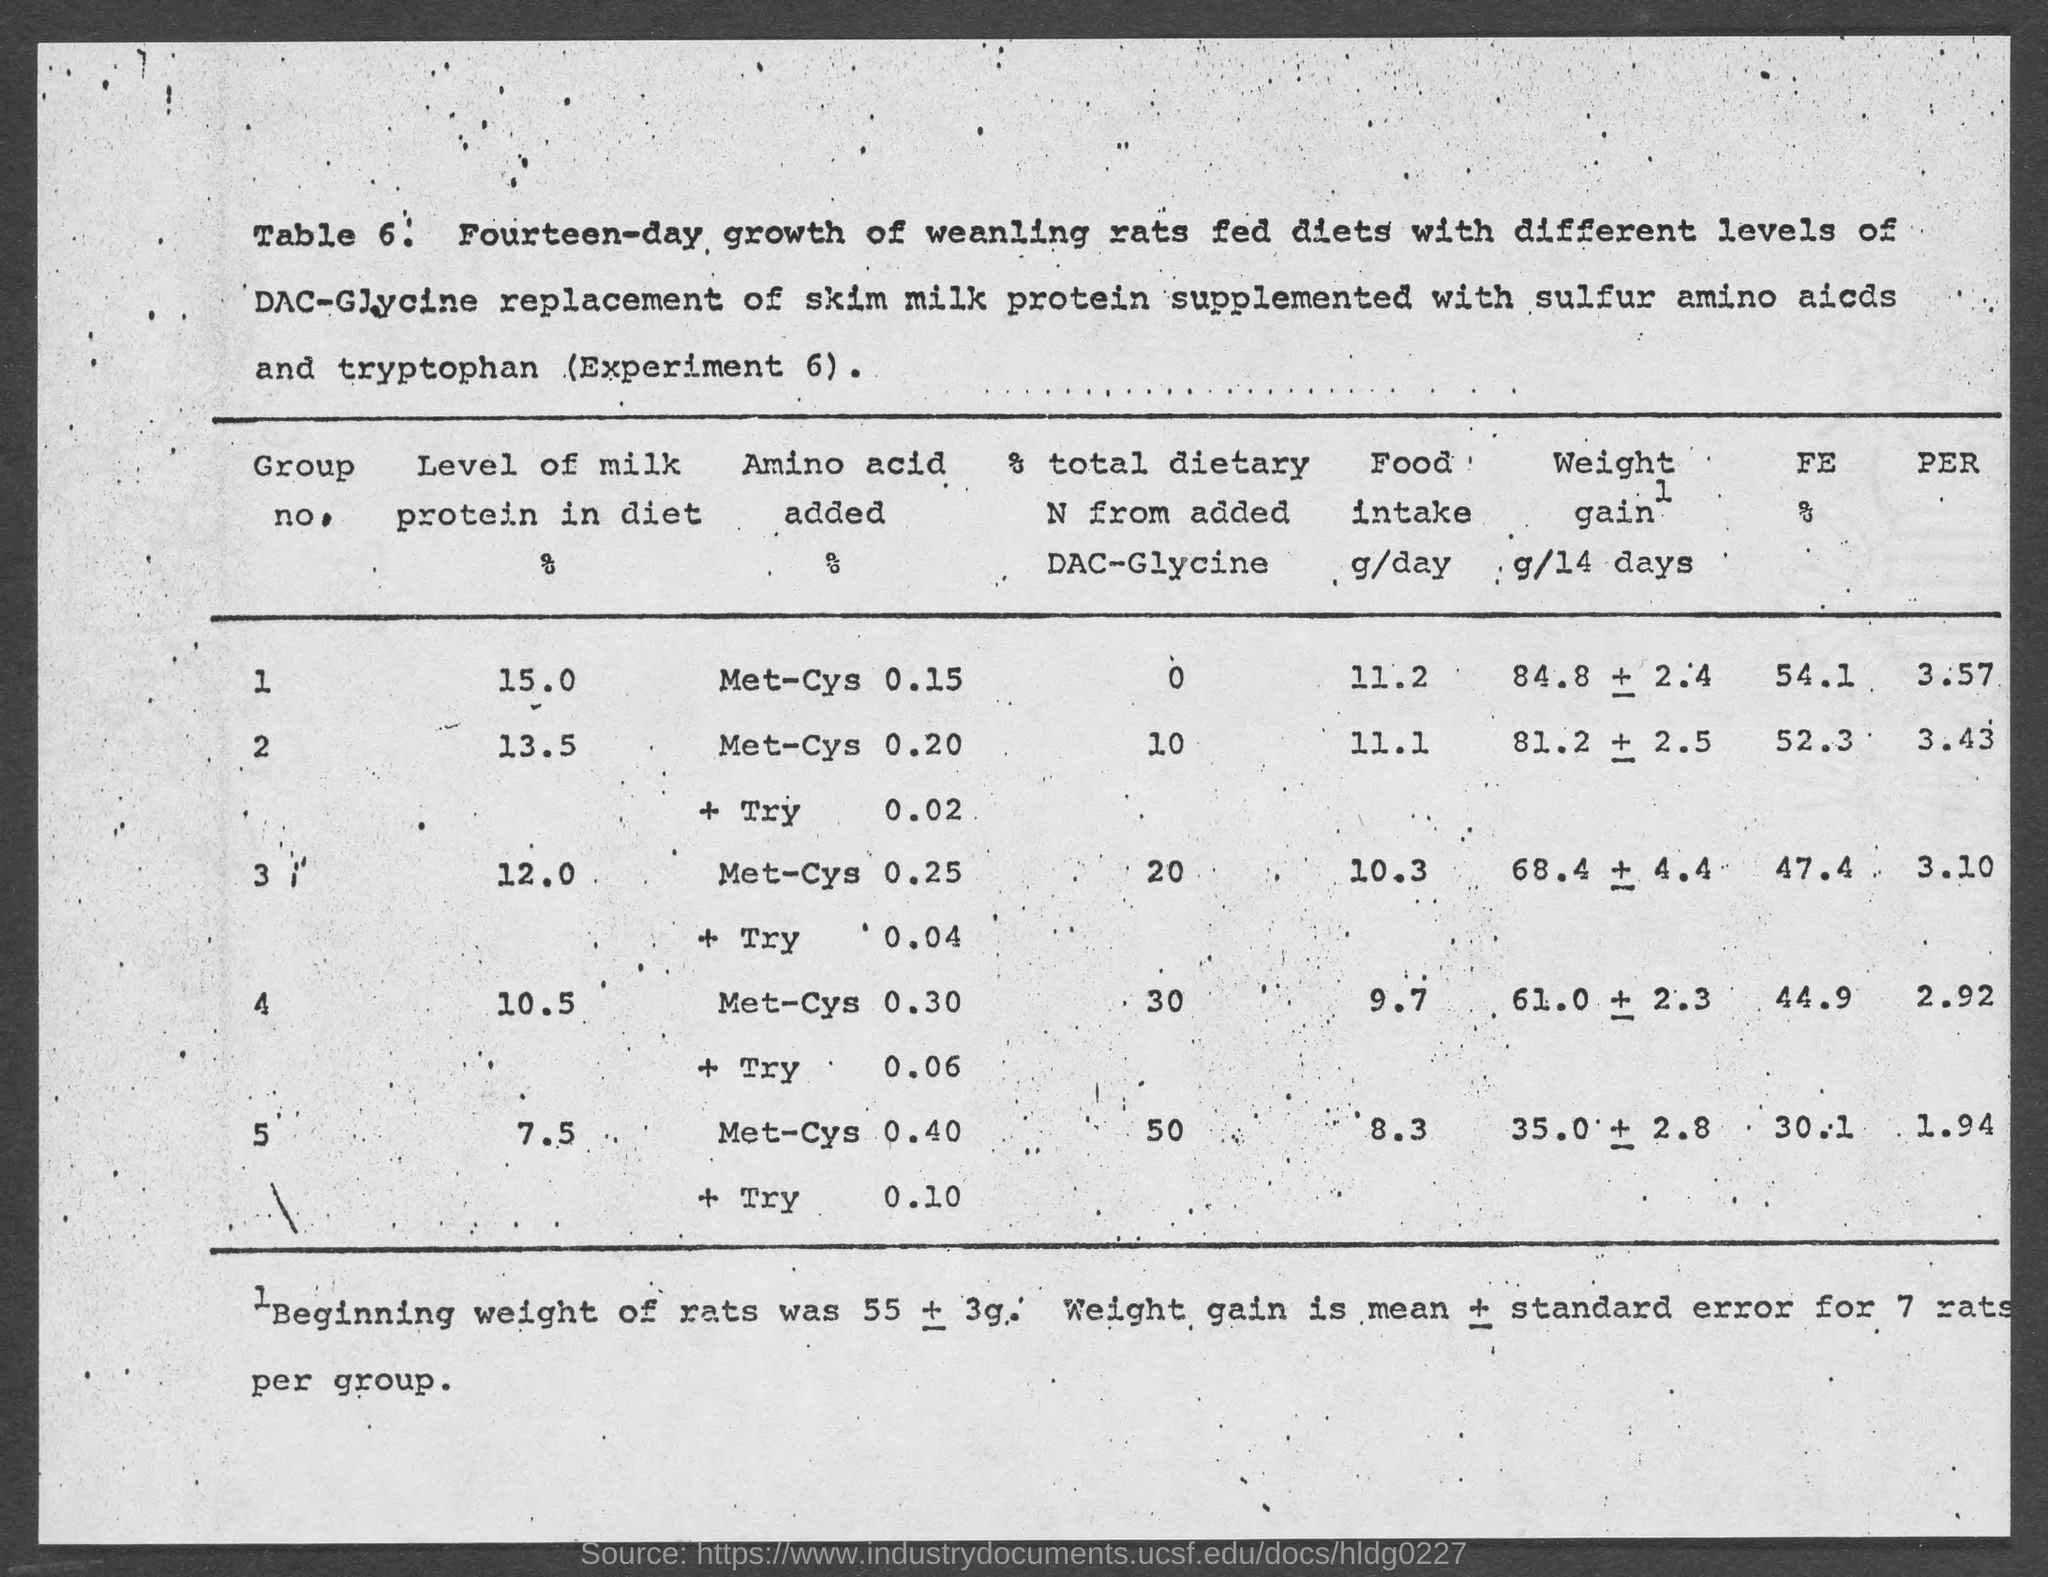Outline some significant characteristics in this image. The consumption of milk protein is low in a particular group. The milk protein intake in group 2 is 13.5%. The level of milk protein in the diet in group 5 is 7.5 grams. The group with the highest levels of milk protein in their diet is... The number is 6. 